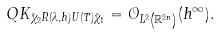Convert formula to latex. <formula><loc_0><loc_0><loc_500><loc_500>Q K _ { \tilde { \chi } _ { 2 } R ( \lambda , h ) U ( T ) \tilde { \chi } _ { 1 } } = \mathcal { O } _ { L ^ { 2 } \left ( \mathbb { R } ^ { 2 n } \right ) } ( h ^ { \infty } ) .</formula> 